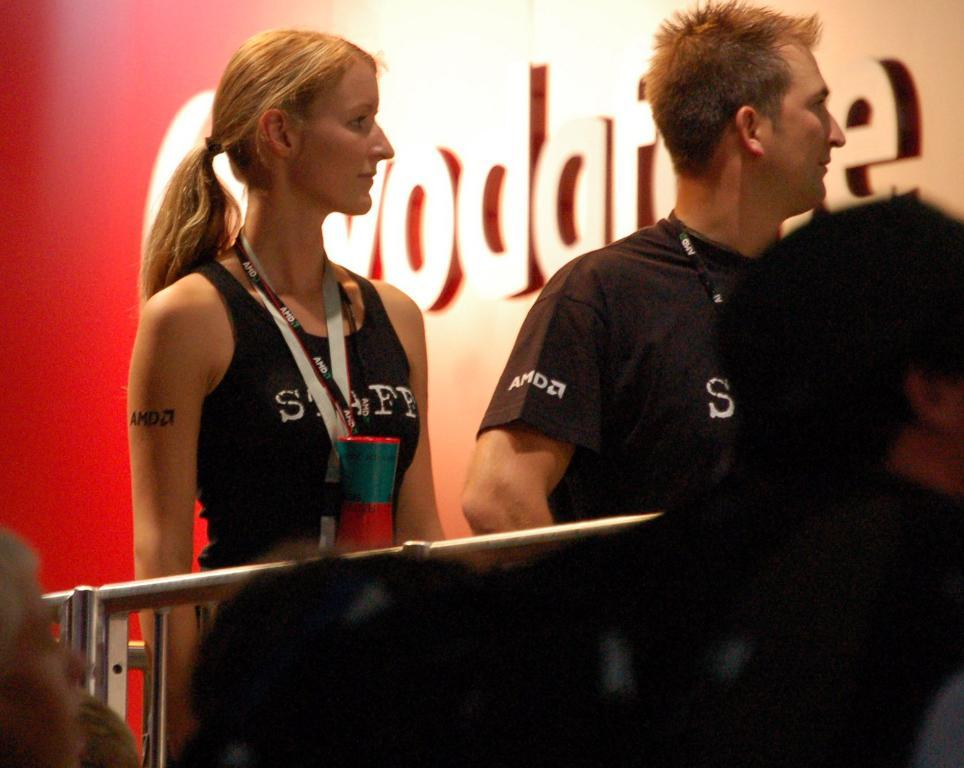Who or what can be seen in the image? There are people in the image. What are some people wearing in the image? Some people are wearing ID cards in the image. What can be seen in the background of the image? There is a board with text in the background of the image. What might be used for support or guidance in the image? There are railings in the image. How many toes are visible on the people in the image? There is no information about the number of toes visible on the people in the image. --- Facts: 1. There is a car in the image. 2. The car is parked on the street. 3. There are trees in the background of the image. 4. The sky is visible in the image. Absurd Topics: parrot, sand, ocean Conversation: What is the main subject of the image? The main subject of the image is a car. Where is the car located in the image? The car is parked on the street in the image. What can be seen in the background of the image? There are trees in the background of the image. What is visible above the car in the image? The sky is visible in the image. Reasoning: Let's think step by step in order to produce the conversation. We start by identifying the main subject in the image, which is the car. Then, we describe the location of the car, which is parked on the street. Next, we mention the background of the image, which includes trees. Finally, we describe the sky visible above the car in the image. Absurd Question/Answer: Can you see a parrot sitting on the car in the image? No, there is no parrot present in the image. --- Facts: 1. There is a person holding a camera in the image. 2. The person is standing on a bridge. 3. There is a river below the bridge. 4. There are mountains in the distance. Absurd Topics: cake, balloon, dance Conversation: What is the person in the image doing? The person in the image is holding a camera. Where is the person standing in the image? The person is standing on a bridge in the image. What can be seen below the bridge in the image? There is a river below the bridge in the image. What can be seen in the distance in the image? There are mountains in the distance in the image. Reasoning: Let's think step by step in order to produce the conversation. We start by identifying the main subject in the image, which is the person holding a camera. Then, we describe the location of the person, which is standing on a bridge. Next, we mention the river below the bridge and the mountains in the distance. Absurd Question/An 